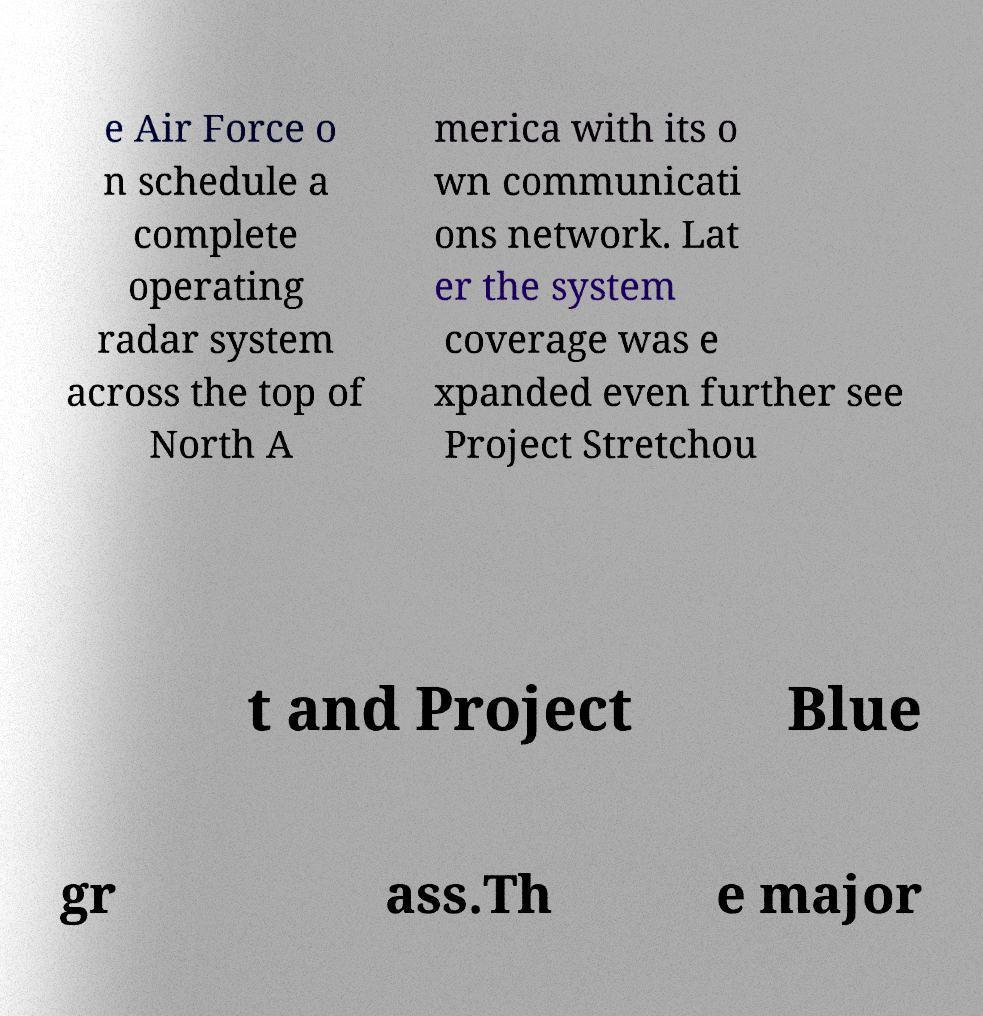Please read and relay the text visible in this image. What does it say? e Air Force o n schedule a complete operating radar system across the top of North A merica with its o wn communicati ons network. Lat er the system coverage was e xpanded even further see Project Stretchou t and Project Blue gr ass.Th e major 